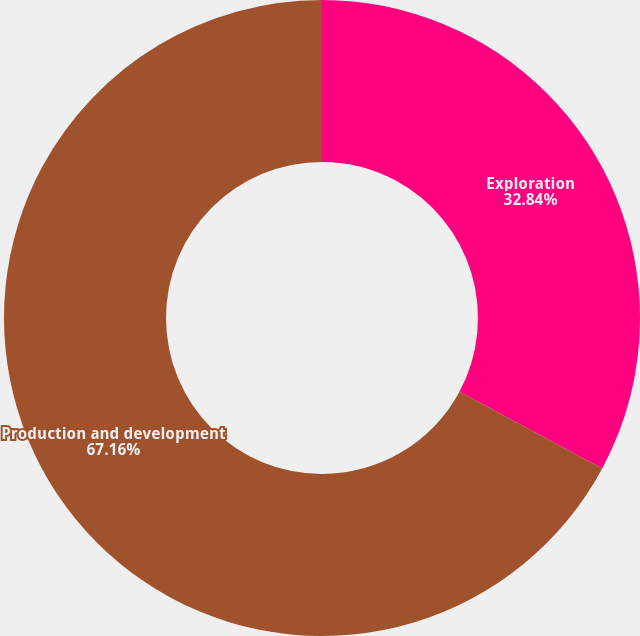<chart> <loc_0><loc_0><loc_500><loc_500><pie_chart><fcel>Exploration<fcel>Production and development<nl><fcel>32.84%<fcel>67.16%<nl></chart> 